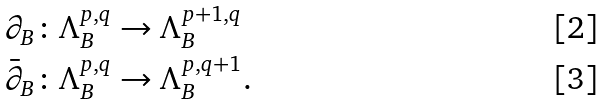<formula> <loc_0><loc_0><loc_500><loc_500>\partial _ { B } \colon & \Lambda _ { B } ^ { p , q } \rightarrow \Lambda _ { B } ^ { p + 1 , q } \\ \bar { \partial } _ { B } \colon & \Lambda _ { B } ^ { p , q } \rightarrow \Lambda _ { B } ^ { p , q + 1 } .</formula> 